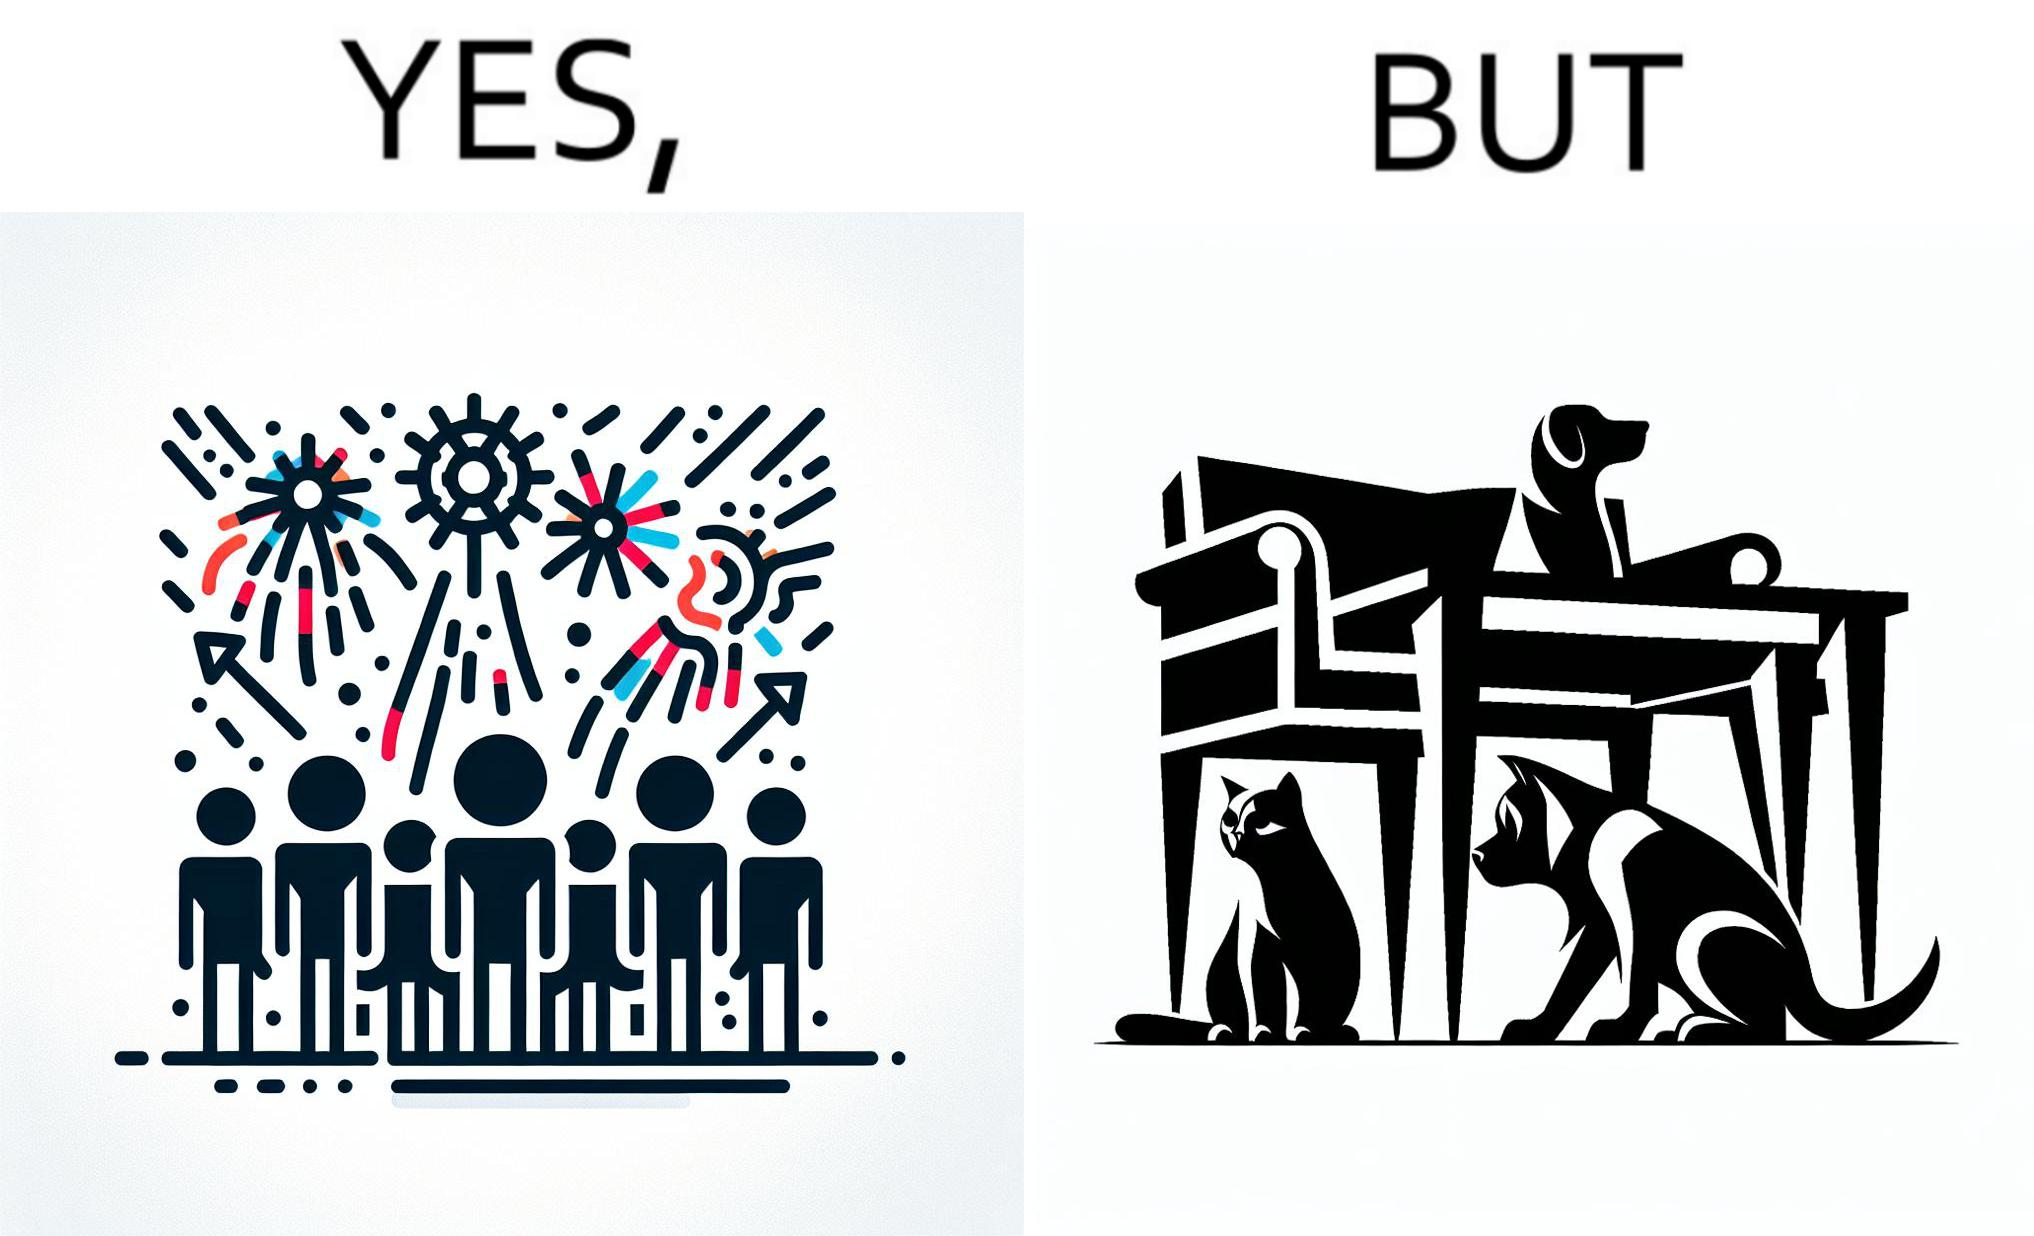What do you see in each half of this image? In the left part of the image: The image shows colorful firecrackers going off in the sky. In the right part of the image: The image shows two dogs and a cat hiding under furniture. 